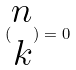Convert formula to latex. <formula><loc_0><loc_0><loc_500><loc_500>( \begin{matrix} n \\ k \end{matrix} ) = 0</formula> 